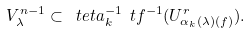Convert formula to latex. <formula><loc_0><loc_0><loc_500><loc_500>V ^ { n - 1 } _ { \lambda } \subset \ t e t a _ { k } ^ { - 1 } \ t f ^ { - 1 } ( U ^ { r } _ { \alpha _ { k } ( \lambda ) ( f ) } ) .</formula> 